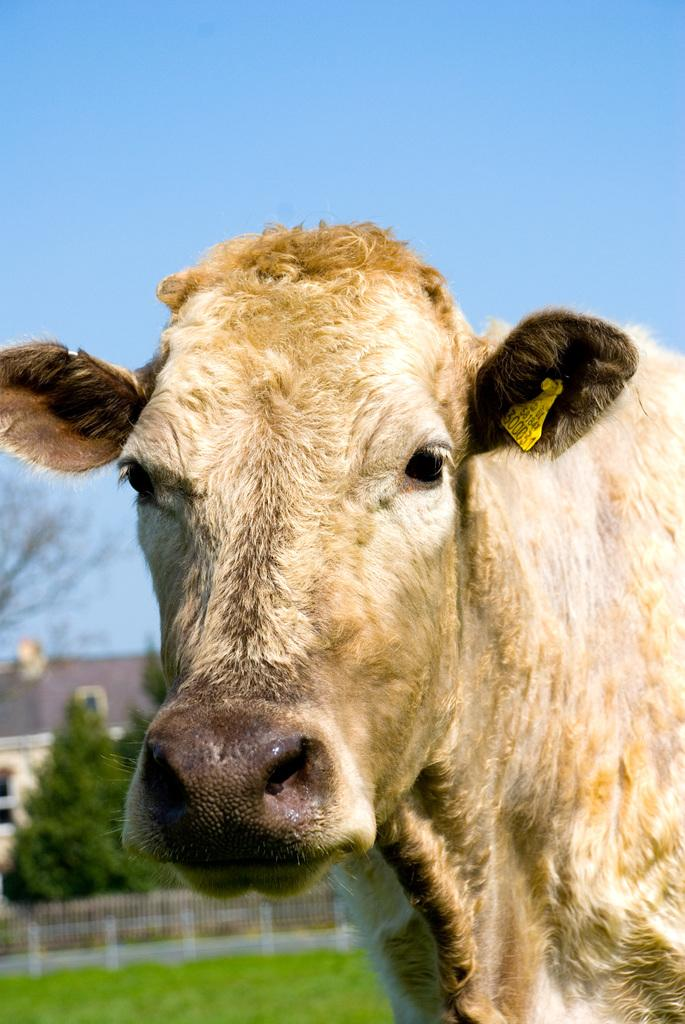What animal is present in the image? There is a cow in the image. What can be seen in the background of the image? There is fencing, trees, plants, a building, and the sky visible in the background of the image. What type of treatment is the cow receiving from its friends in the image? There is no indication in the image that the cow is receiving any treatment or interacting with friends, as the cow is the only animal present. 